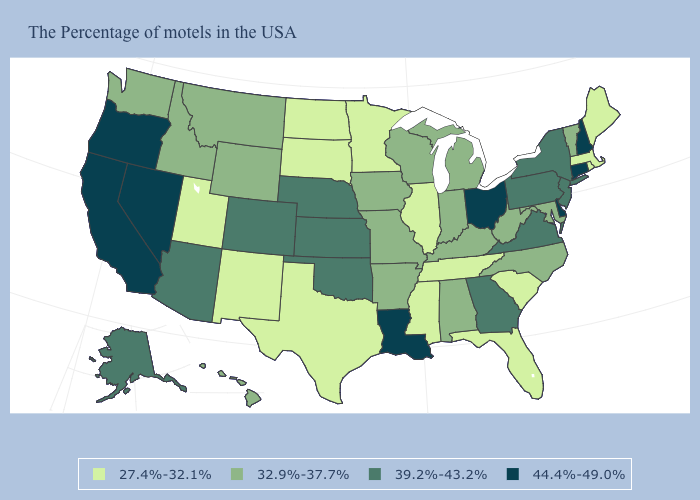Does Ohio have the highest value in the MidWest?
Write a very short answer. Yes. Which states have the highest value in the USA?
Keep it brief. New Hampshire, Connecticut, Delaware, Ohio, Louisiana, Nevada, California, Oregon. Does the first symbol in the legend represent the smallest category?
Short answer required. Yes. Name the states that have a value in the range 27.4%-32.1%?
Answer briefly. Maine, Massachusetts, Rhode Island, South Carolina, Florida, Tennessee, Illinois, Mississippi, Minnesota, Texas, South Dakota, North Dakota, New Mexico, Utah. Does Louisiana have the same value as Maryland?
Keep it brief. No. What is the lowest value in the USA?
Quick response, please. 27.4%-32.1%. What is the value of Iowa?
Keep it brief. 32.9%-37.7%. What is the lowest value in the USA?
Give a very brief answer. 27.4%-32.1%. Is the legend a continuous bar?
Short answer required. No. Does Tennessee have the lowest value in the South?
Concise answer only. Yes. What is the value of Minnesota?
Write a very short answer. 27.4%-32.1%. Which states have the highest value in the USA?
Quick response, please. New Hampshire, Connecticut, Delaware, Ohio, Louisiana, Nevada, California, Oregon. What is the value of Kentucky?
Write a very short answer. 32.9%-37.7%. What is the lowest value in the West?
Concise answer only. 27.4%-32.1%. Does Michigan have the lowest value in the USA?
Give a very brief answer. No. 